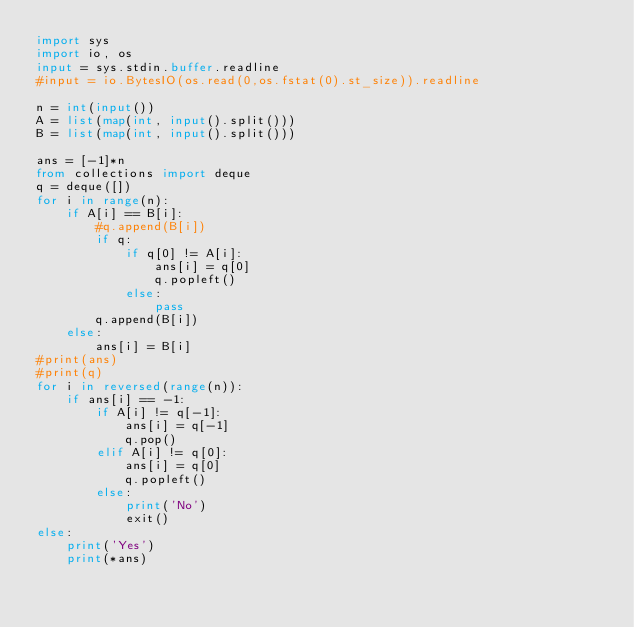Convert code to text. <code><loc_0><loc_0><loc_500><loc_500><_Python_>import sys
import io, os
input = sys.stdin.buffer.readline
#input = io.BytesIO(os.read(0,os.fstat(0).st_size)).readline

n = int(input())
A = list(map(int, input().split()))
B = list(map(int, input().split()))

ans = [-1]*n
from collections import deque
q = deque([])
for i in range(n):
    if A[i] == B[i]:
        #q.append(B[i])
        if q:
            if q[0] != A[i]:
                ans[i] = q[0]
                q.popleft()
            else:
                pass
        q.append(B[i])
    else:
        ans[i] = B[i]
#print(ans)
#print(q)
for i in reversed(range(n)):
    if ans[i] == -1:
        if A[i] != q[-1]:
            ans[i] = q[-1]
            q.pop()
        elif A[i] != q[0]:
            ans[i] = q[0]
            q.popleft()
        else:
            print('No')
            exit()
else:
    print('Yes')
    print(*ans)
</code> 